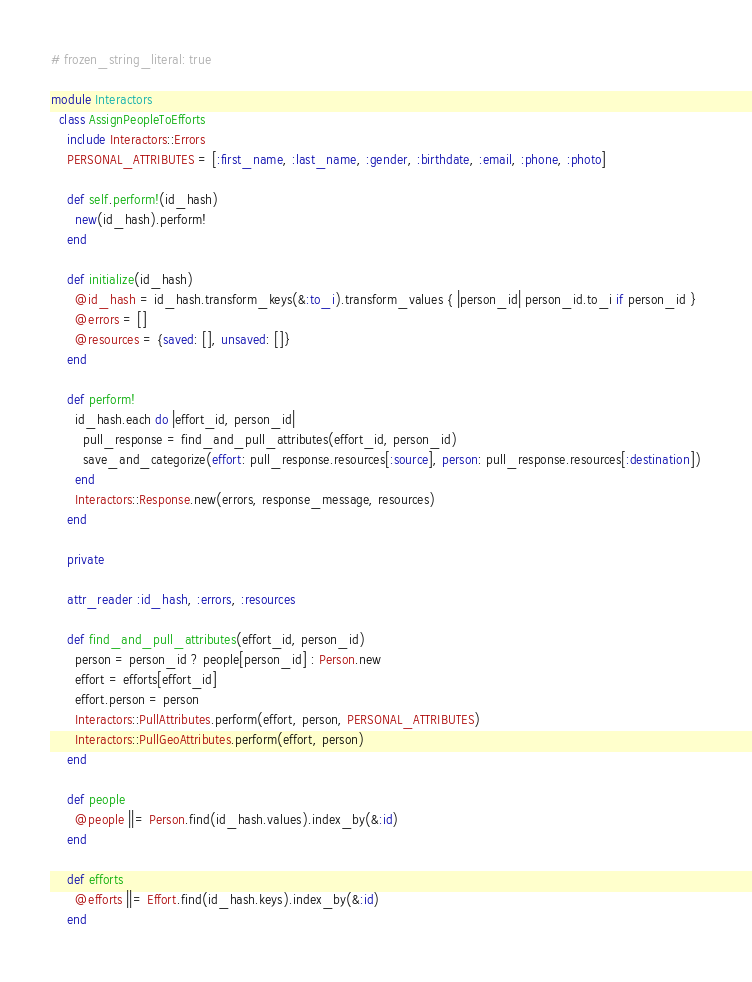<code> <loc_0><loc_0><loc_500><loc_500><_Ruby_># frozen_string_literal: true

module Interactors
  class AssignPeopleToEfforts
    include Interactors::Errors
    PERSONAL_ATTRIBUTES = [:first_name, :last_name, :gender, :birthdate, :email, :phone, :photo]

    def self.perform!(id_hash)
      new(id_hash).perform!
    end

    def initialize(id_hash)
      @id_hash = id_hash.transform_keys(&:to_i).transform_values { |person_id| person_id.to_i if person_id }
      @errors = []
      @resources = {saved: [], unsaved: []}
    end

    def perform!
      id_hash.each do |effort_id, person_id|
        pull_response = find_and_pull_attributes(effort_id, person_id)
        save_and_categorize(effort: pull_response.resources[:source], person: pull_response.resources[:destination])
      end
      Interactors::Response.new(errors, response_message, resources)
    end

    private

    attr_reader :id_hash, :errors, :resources

    def find_and_pull_attributes(effort_id, person_id)
      person = person_id ? people[person_id] : Person.new
      effort = efforts[effort_id]
      effort.person = person
      Interactors::PullAttributes.perform(effort, person, PERSONAL_ATTRIBUTES)
      Interactors::PullGeoAttributes.perform(effort, person)
    end

    def people
      @people ||= Person.find(id_hash.values).index_by(&:id)
    end

    def efforts
      @efforts ||= Effort.find(id_hash.keys).index_by(&:id)
    end
</code> 